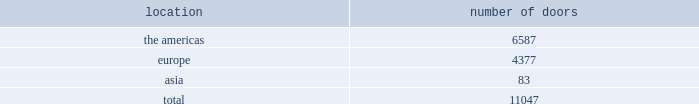Worldwide distribution channels the table presents the number of doors by geographic location , in which ralph lauren-branded products distributed by our wholesale segment were sold to consumers in our primary channels of distribution as of march 31 , 2012 : location number of .
In addition , american living and chaps-branded products distributed by our wholesale segment were sold domestically through approximately 1800 doors as of march 31 , 2012 .
We have three key wholesale customers that generate significant sales volume .
For fiscal 2012 , these customers in the aggregate accounted for approximately 40% ( 40 % ) of total wholesale revenues , with macy 2019s , inc .
Representing approximately 20% ( 20 % ) of total wholesale revenues .
Our product brands are sold primarily through our own sales forces .
Our wholesale segment maintains its primary showrooms in new york city .
In addition , we maintain regional showrooms in chicago , dallas , milan , paris , london , munich , madrid , stockholm and tokyo .
Shop-within-shops .
As a critical element of our distribution to department stores , we and our licensing partners utilize shop-within-shops to enhance brand recognition , to permit more complete merchandising of our lines by the department stores and to differentiate the presentation of products .
Shop-within- shop fixed assets primarily include items such as customized freestanding fixtures , wall cases and components , decorative items and flooring .
As of march 31 , 2012 , we had approximately 18000 shop-within-shops dedicated to our ralph lauren-branded wholesale products worldwide .
The size of our shop-within-shops ranges from approximately 300 to 7400 square feet .
We normally share in the cost of building-out these shop-within-shops with our wholesale customers .
Basic stock replenishment program .
Basic products such as knit shirts , chino pants , oxford cloth shirts , and selected accessories ( including footwear ) and home products can be ordered at any time through our basic stock replenishment programs .
We generally ship these products within two-to-five days of order receipt .
Our retail segment as of march 31 , 2012 , our retail segment consisted of 379 stores worldwide , totaling approximately 2.9 million gross square feet , 474 concessions- based shop-within-shops and six e-commerce websites .
The extension of our direct-to-consumer reach is a primary long-term strategic goal .
Ralph lauren retail stores our ralph lauren retail stores reinforce the luxury image and distinct sensibility of our brands and feature exclusive lines that are not sold in domestic department stores .
We opened 10 new ralph lauren stores , acquired 3 previously licensed stores , and closed 16 ralph lauren stores in fiscal 2012 .
Our retail stores are primarily situated in major upscale street locations and upscale regional malls , generally in large urban markets. .
What percentage of worldwide distribution channels doors as of march 31 , 2012 where in the americas? 
Computations: (6587 / 11047)
Answer: 0.59627. 